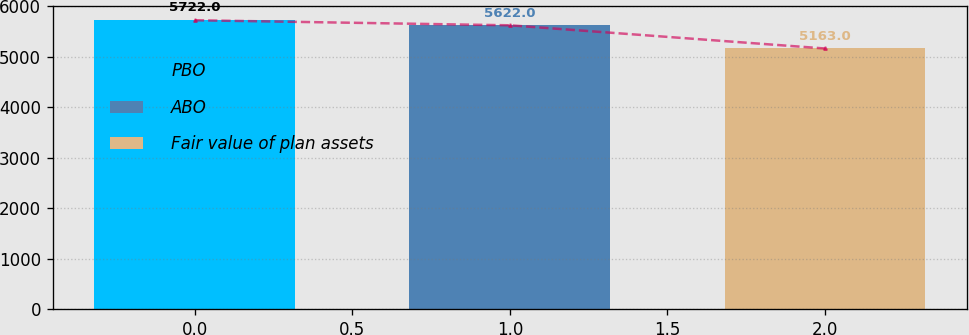<chart> <loc_0><loc_0><loc_500><loc_500><bar_chart><fcel>PBO<fcel>ABO<fcel>Fair value of plan assets<nl><fcel>5722<fcel>5622<fcel>5163<nl></chart> 